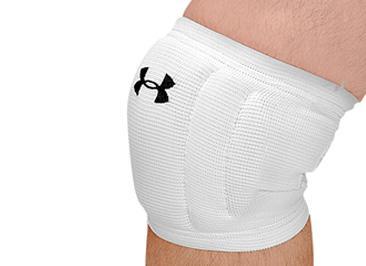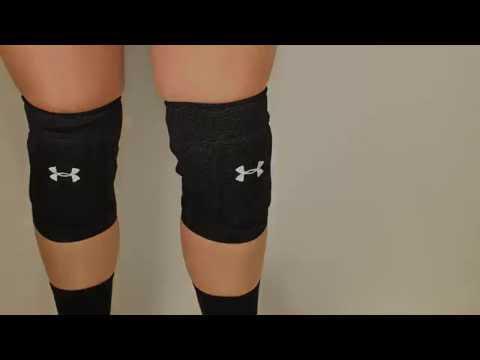The first image is the image on the left, the second image is the image on the right. Analyze the images presented: Is the assertion "One image features a pair of legs wearing knee pads, and the other image includes a white knee pad." valid? Answer yes or no. Yes. 